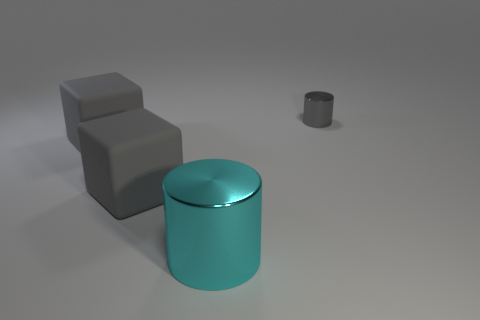Is there anything else that has the same size as the gray metallic object?
Offer a very short reply. No. Are there more cyan cylinders than tiny purple matte balls?
Provide a succinct answer. Yes. There is a cylinder that is in front of the tiny object behind the big cyan metallic thing left of the tiny cylinder; what is it made of?
Provide a short and direct response. Metal. There is a object that is to the right of the cyan object; does it have the same color as the metallic cylinder that is in front of the small metallic cylinder?
Offer a terse response. No. What shape is the gray thing on the right side of the metallic object on the left side of the object to the right of the large cyan shiny cylinder?
Keep it short and to the point. Cylinder. There is a shiny thing behind the metal thing that is in front of the small gray object; how many gray matte cubes are behind it?
Ensure brevity in your answer.  0. What size is the cyan object that is the same shape as the small gray shiny object?
Make the answer very short. Large. Are the cylinder in front of the small gray object and the small cylinder made of the same material?
Provide a short and direct response. Yes. The other small metal thing that is the same shape as the cyan thing is what color?
Provide a short and direct response. Gray. What number of other objects are there of the same color as the big cylinder?
Give a very brief answer. 0. 